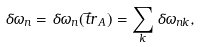Convert formula to latex. <formula><loc_0><loc_0><loc_500><loc_500>\delta \omega _ { n } = \delta \omega _ { n } ( \vec { t } { r } _ { \, A } ) = \sum _ { k } \delta \omega _ { n k } ,</formula> 